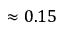<formula> <loc_0><loc_0><loc_500><loc_500>\approx 0 . 1 5</formula> 